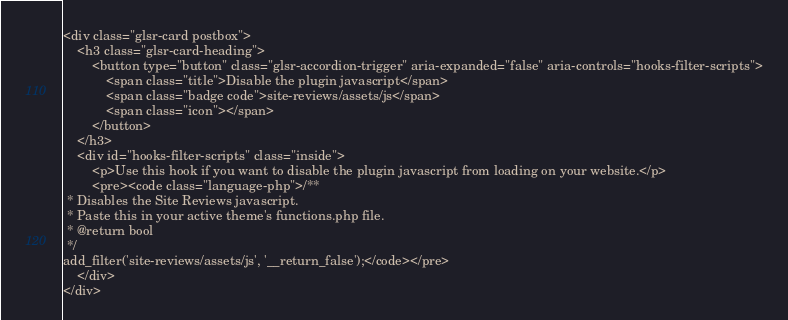<code> <loc_0><loc_0><loc_500><loc_500><_PHP_><div class="glsr-card postbox">
    <h3 class="glsr-card-heading">
        <button type="button" class="glsr-accordion-trigger" aria-expanded="false" aria-controls="hooks-filter-scripts">
            <span class="title">Disable the plugin javascript</span>
            <span class="badge code">site-reviews/assets/js</span>
            <span class="icon"></span>
        </button>
    </h3>
    <div id="hooks-filter-scripts" class="inside">
        <p>Use this hook if you want to disable the plugin javascript from loading on your website.</p>
        <pre><code class="language-php">/**
 * Disables the Site Reviews javascript.
 * Paste this in your active theme's functions.php file.
 * @return bool
 */
add_filter('site-reviews/assets/js', '__return_false');</code></pre>
    </div>
</div>
</code> 